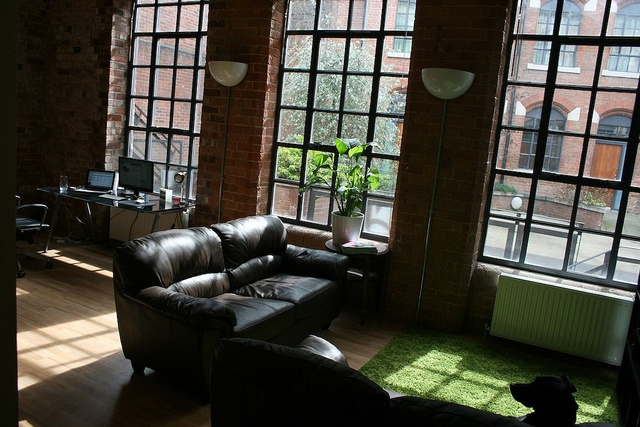Describe the objects in this image and their specific colors. I can see couch in black, gray, darkgray, and white tones, potted plant in black, gray, darkgray, and darkgreen tones, dog in black, khaki, lightgreen, and darkgreen tones, chair in black, darkgray, and gray tones, and tv in black, gray, and white tones in this image. 